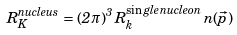Convert formula to latex. <formula><loc_0><loc_0><loc_500><loc_500>R _ { K } ^ { n u c l e u s } = ( 2 \pi ) ^ { 3 } \, R _ { k } ^ { \sin g l e \, n u c l e o n } \, n ( \vec { p } )</formula> 